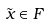Convert formula to latex. <formula><loc_0><loc_0><loc_500><loc_500>\tilde { x } \in F</formula> 